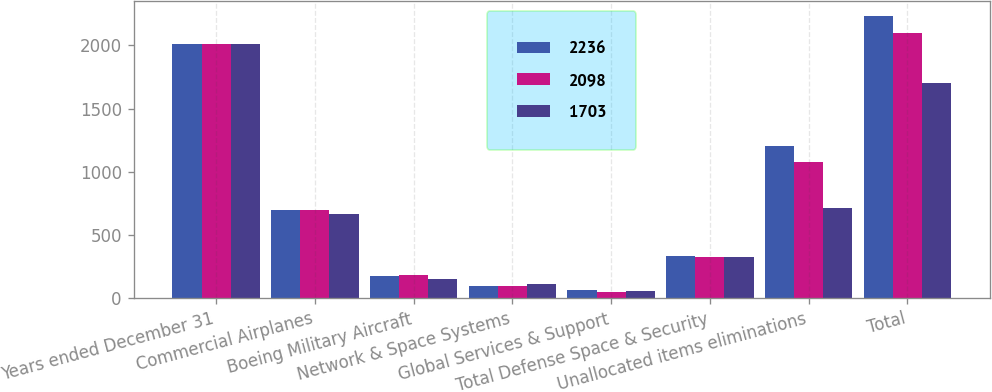Convert chart to OTSL. <chart><loc_0><loc_0><loc_500><loc_500><stacked_bar_chart><ecel><fcel>Years ended December 31<fcel>Commercial Airplanes<fcel>Boeing Military Aircraft<fcel>Network & Space Systems<fcel>Global Services & Support<fcel>Total Defense Space & Security<fcel>Unallocated items eliminations<fcel>Total<nl><fcel>2236<fcel>2014<fcel>698<fcel>175<fcel>93<fcel>68<fcel>336<fcel>1202<fcel>2236<nl><fcel>2098<fcel>2013<fcel>694<fcel>186<fcel>96<fcel>48<fcel>330<fcel>1074<fcel>2098<nl><fcel>1703<fcel>2012<fcel>665<fcel>153<fcel>115<fcel>57<fcel>325<fcel>713<fcel>1703<nl></chart> 